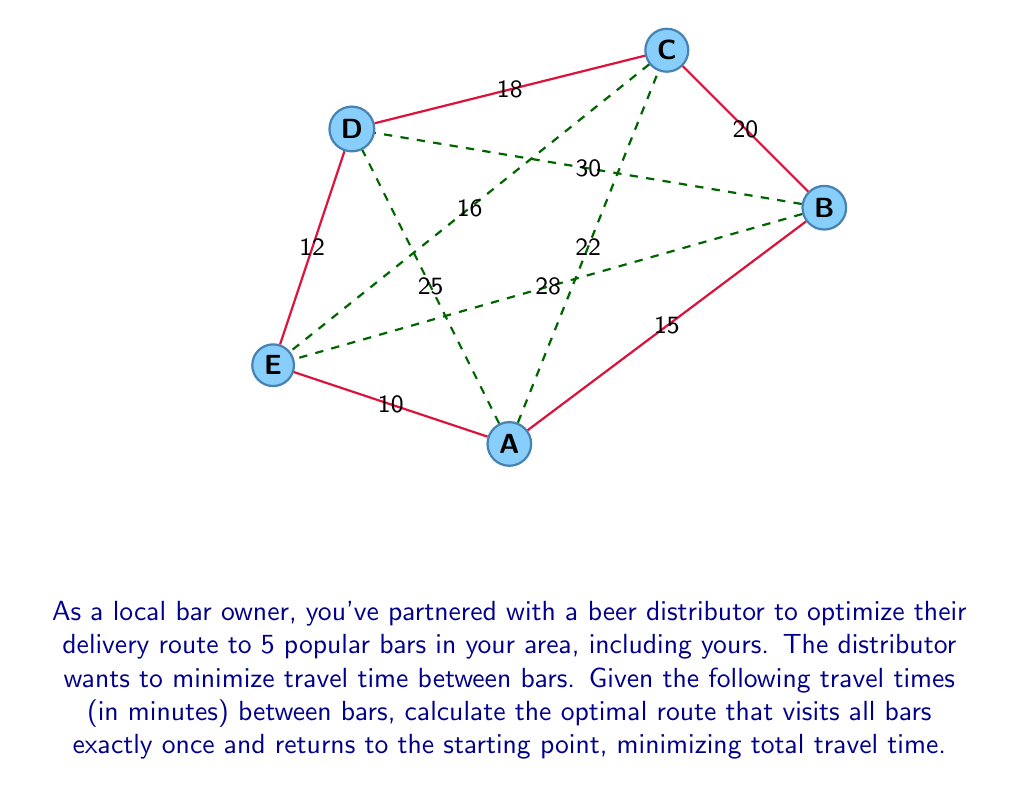Could you help me with this problem? To solve this problem, we'll use the Held-Karp algorithm, which is an efficient method for solving the Traveling Salesman Problem (TSP) using dynamic programming.

Step 1: Initialize the base cases
For each pair of bars (i, j), calculate the cost of going from i to j directly:
$$C(\{i\}, i) = 0$$
$$C(\{i,j\}, j) = \text{distance}(i,j)$$

Step 2: Build up subproblems
For subsets S of size 2 to n-1, and for each j in S, calculate:
$$C(S,j) = \min_{i \in S, i \neq j} \{C(S-\{j\},i) + \text{distance}(i,j)\}$$

Step 3: Find the optimal solution
$$\text{opt} = \min_{j \neq 1} \{C(\{1,2,3,4,5\}-\{1\},j) + \text{distance}(j,1)\}$$

Step 4: Reconstruct the path
Backtrack through the dynamic programming table to find the optimal path.

Applying this to our specific problem:

1. Initialize base cases (omitted for brevity)
2. Build subproblems (partial calculation shown):
   $$C(\{A,B\},B) = 15$$
   $$C(\{A,B,C\},C) = \min\{C(\{A,B\},A) + 22, C(\{A,B\},B) + 20\} = 35$$
   ...
3. Find optimal solution:
   $$\text{opt} = \min\{C(\{B,C,D,E\},B) + 15, C(\{B,C,D,E\},C) + 22, ....\}$$
4. Reconstruct path: A → E → D → C → B → A

The total distance for this optimal path is: 10 + 12 + 18 + 20 + 15 = 75 minutes.
Answer: A → E → D → C → B → A, 75 minutes 